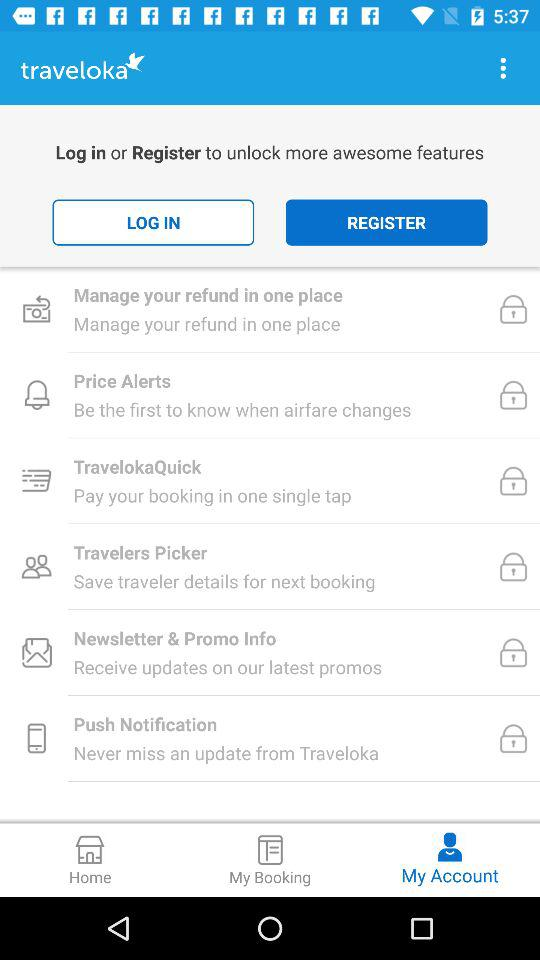What is the name of the application? The name of the application is "traveloka". 